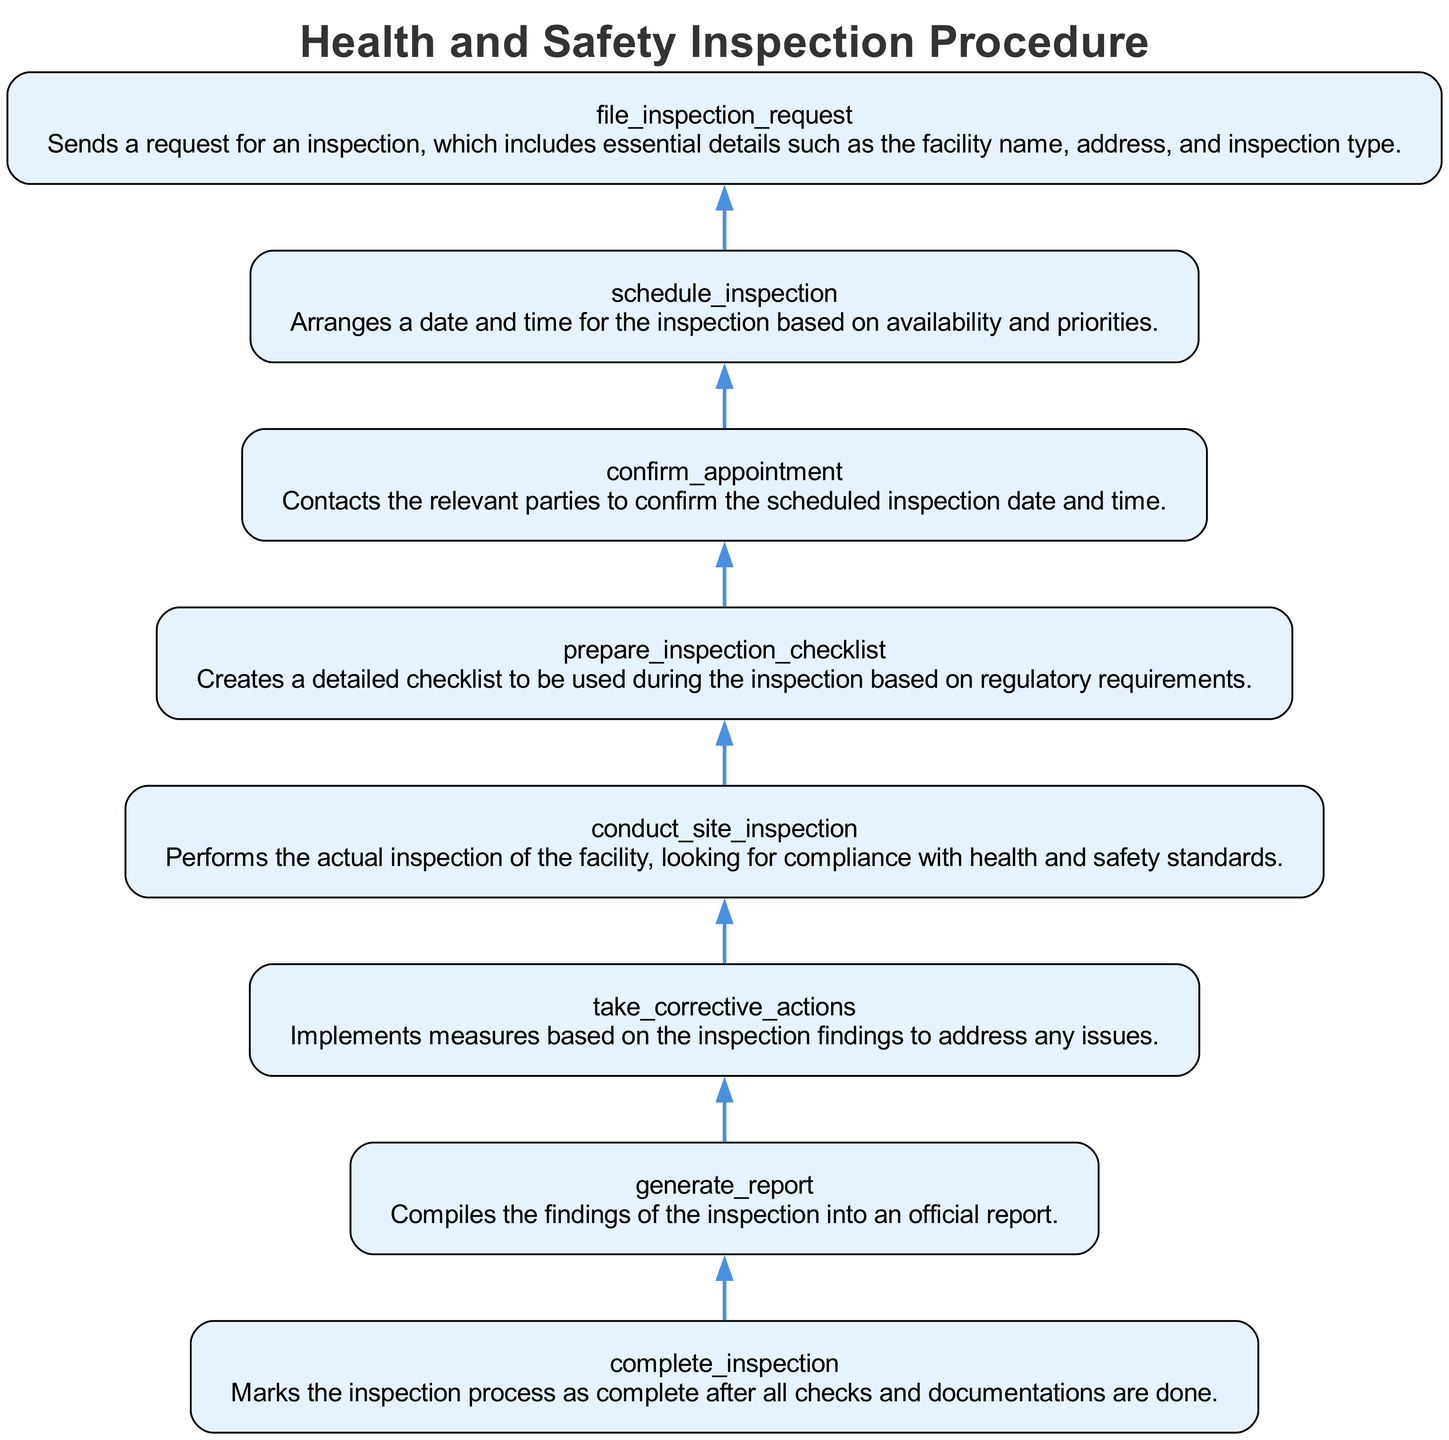What is the first step in the inspection procedure? The first step indicated in the diagram is "file inspection request." This is the initial node at the bottom of the flowchart, from which the process begins.
Answer: file inspection request How many total nodes are present in the flowchart? By counting the different steps listed in the diagram, we find that there are a total of eight nodes, each representing a step in the health and safety inspection procedure.
Answer: eight What follows after scheduling the inspection? The node that comes directly after "schedule inspection" is "confirm appointment," indicating that confirmation follows the scheduling process in the flow.
Answer: confirm appointment What is the last action taken in the inspection process? The last action in the process, as per the flow, is "complete inspection," which signifies the end of the inspection procedure after all necessary checks and documentations are done.
Answer: complete inspection Which function is implemented based on inspection findings? The function that takes corrective actions based on the inspection findings is "take corrective actions," reflecting that this step is necessary to resolve any identified issues.
Answer: take corrective actions Explain the relationship between "conduct site inspection" and "generate report." "conduct site inspection" must occur before "generate report." The inspection of the site provides necessary data that is later compiled into an official report, following the flow of information from one node to the next.
Answer: conduct site inspection leads to generate report What step directly precedes "complete inspection"? The step that directly comes before "complete inspection" is "take corrective actions." This indicates that after addressing any issues, the inspection can then be marked as complete.
Answer: take corrective actions What does the "prepare inspection checklist" function achieve? The "prepare inspection checklist" function creates a detailed checklist based on regulatory requirements, which is critical for guiding the inspectors during the site inspection.
Answer: creates checklist 